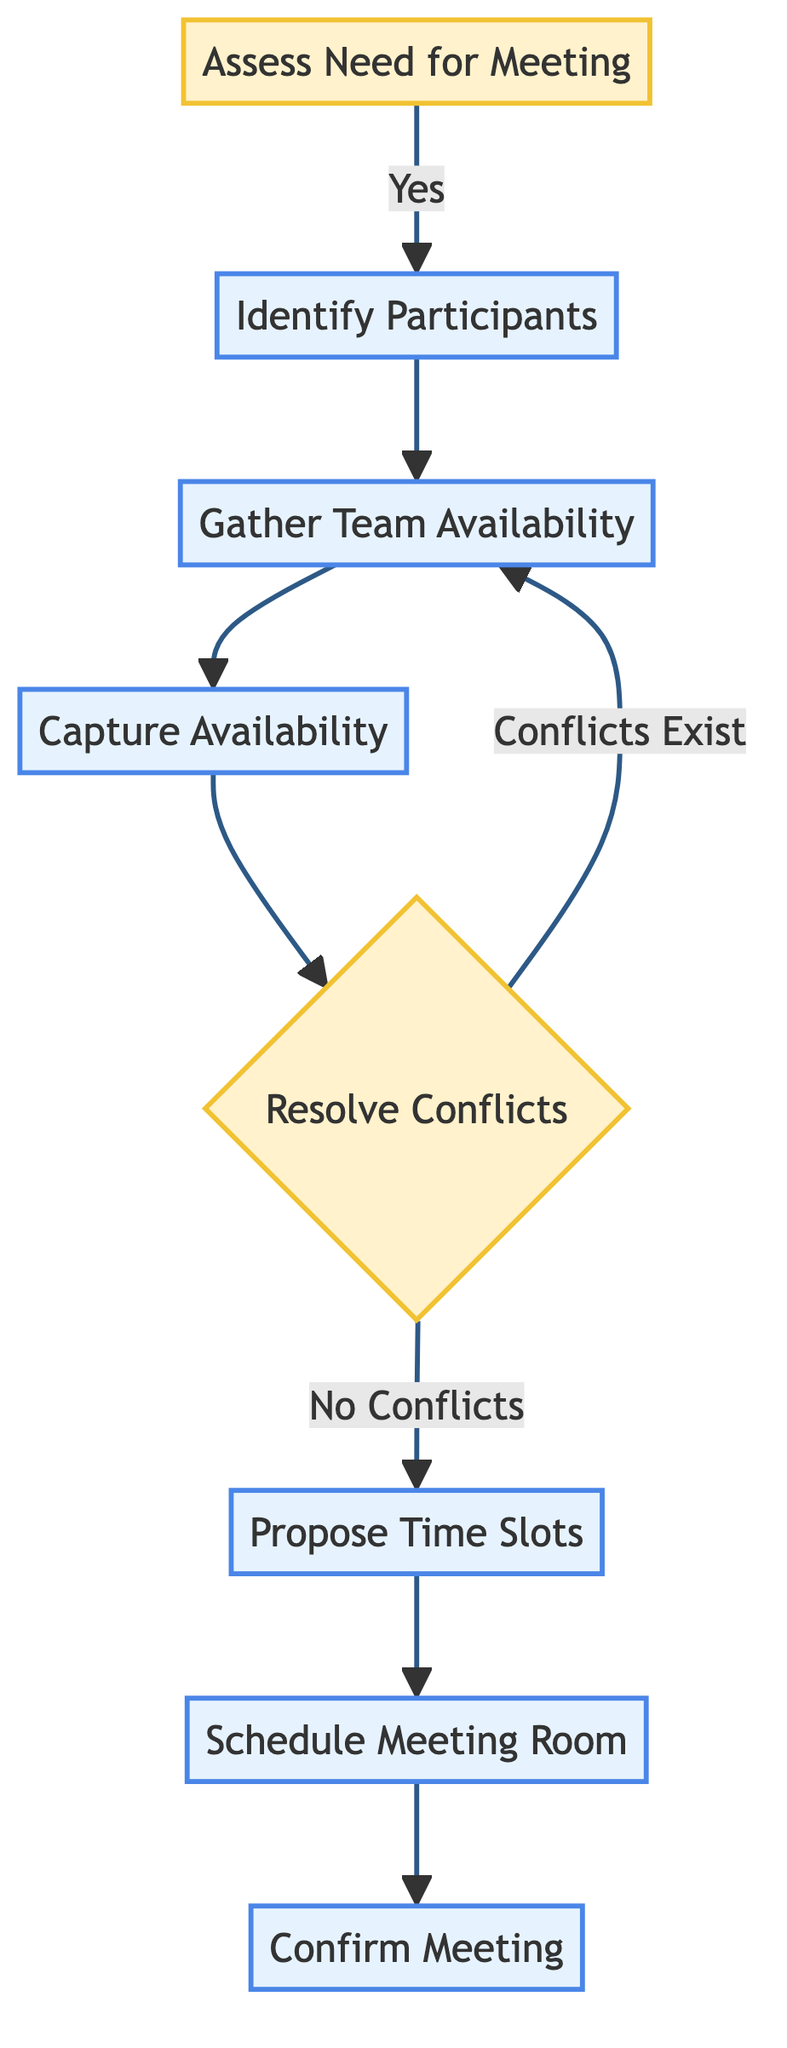What's the first step in the process? The process starts with the node labeled "Assess Need for Meeting." This node determines if there is a requirement for a meeting based on current workload and tasks.
Answer: Assess Need for Meeting How many actions are present in the flowchart? The flowchart has five actions: "Identify Participants," "Gather Team Availability," "Capture Availability," "Propose Time Slots," and "Schedule Meeting Room." Counting only the nodes labeled as actions leads to this result.
Answer: Five What happens if there are conflicts in availability? If conflicts exist, the flow returns to the "Gather Team Availability" node to request further available times, indicating a reassessment of schedules is needed.
Answer: Return to Gather Team Availability What condition leads to confirming the meeting? The meeting is confirmed after scheduling the meeting room and proposing time slots without any conflicts among team members. This is shown sequentially in the flowchart.
Answer: No Conflicts Which node follows "Capture Availability"? After "Capture Availability," the next node is "Resolve Conflicts," where conflicts in scheduling are assessed. This shows the progression of the flow from one node to the next.
Answer: Resolve Conflicts How many decision points are in the diagram? The diagram has two decision points: "Assess Need for Meeting" and "Resolve Conflicts," which directs the flow based on specific criteria.
Answer: Two What is the relationship between "Propose Time Slots" and "Schedule Meeting Room"? "Propose Time Slots" must be completed before moving to "Schedule Meeting Room," indicating a sequential relationship where scheduling the room depends on proposing available times.
Answer: Sequential What is the final action in the meeting scheduling process? The final action after completing all prior steps is "Confirm Meeting," where invites and agendas are sent to participants indicating the end of the process.
Answer: Confirm Meeting 